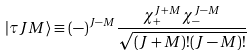Convert formula to latex. <formula><loc_0><loc_0><loc_500><loc_500>| \tau J M \rangle \equiv ( - ) ^ { J - M } \frac { \chi _ { + } ^ { J + M } \chi _ { - } ^ { J - M } } { \sqrt { ( J + M ) ! ( J - M ) ! } }</formula> 